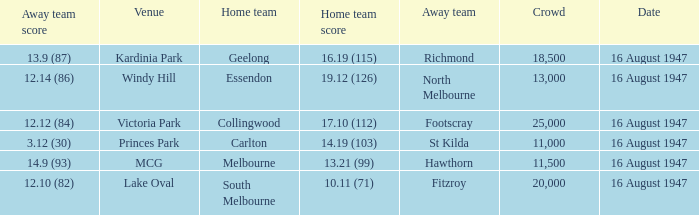What was the total size of the crowd when the away team scored 12.10 (82)? 20000.0. 